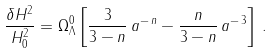<formula> <loc_0><loc_0><loc_500><loc_500>\frac { \delta H ^ { 2 } } { H _ { 0 } ^ { 2 } } = \Omega _ { \Lambda } ^ { 0 } \left [ \frac { 3 } { 3 - n } \, a ^ { - \, n } - \frac { n } { 3 - n } \, a ^ { - \, 3 } \right ] \, .</formula> 